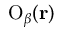<formula> <loc_0><loc_0><loc_500><loc_500>{ { \mathrm O } _ { \beta } } ( r )</formula> 